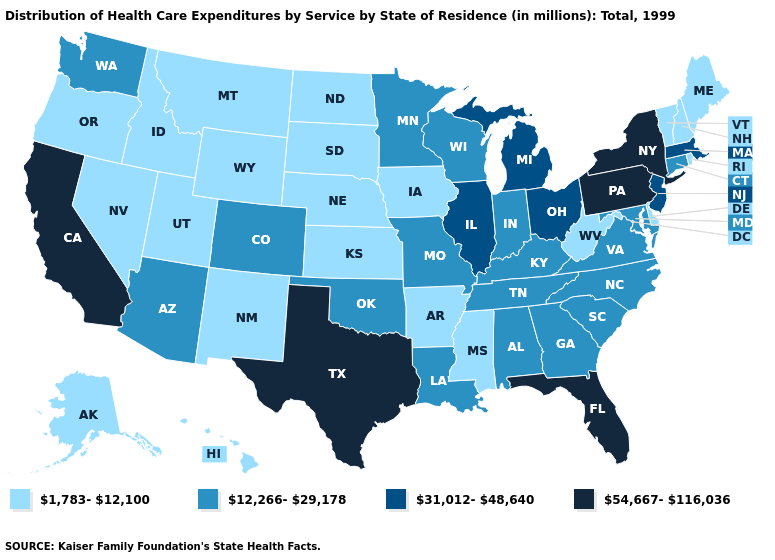Is the legend a continuous bar?
Concise answer only. No. Among the states that border Rhode Island , which have the highest value?
Quick response, please. Massachusetts. What is the highest value in the USA?
Answer briefly. 54,667-116,036. Name the states that have a value in the range 12,266-29,178?
Quick response, please. Alabama, Arizona, Colorado, Connecticut, Georgia, Indiana, Kentucky, Louisiana, Maryland, Minnesota, Missouri, North Carolina, Oklahoma, South Carolina, Tennessee, Virginia, Washington, Wisconsin. What is the highest value in states that border Delaware?
Give a very brief answer. 54,667-116,036. Does California have the highest value in the West?
Quick response, please. Yes. Which states have the lowest value in the MidWest?
Give a very brief answer. Iowa, Kansas, Nebraska, North Dakota, South Dakota. What is the lowest value in the USA?
Give a very brief answer. 1,783-12,100. Which states hav the highest value in the MidWest?
Keep it brief. Illinois, Michigan, Ohio. Does Texas have the lowest value in the USA?
Concise answer only. No. Name the states that have a value in the range 54,667-116,036?
Keep it brief. California, Florida, New York, Pennsylvania, Texas. Is the legend a continuous bar?
Keep it brief. No. What is the lowest value in the USA?
Short answer required. 1,783-12,100. Is the legend a continuous bar?
Answer briefly. No. What is the value of Florida?
Quick response, please. 54,667-116,036. 